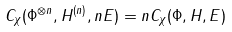Convert formula to latex. <formula><loc_0><loc_0><loc_500><loc_500>C _ { \chi } ( \Phi ^ { \otimes n } , H ^ { ( n ) } , n E ) = n C _ { \chi } ( \Phi , H , E )</formula> 